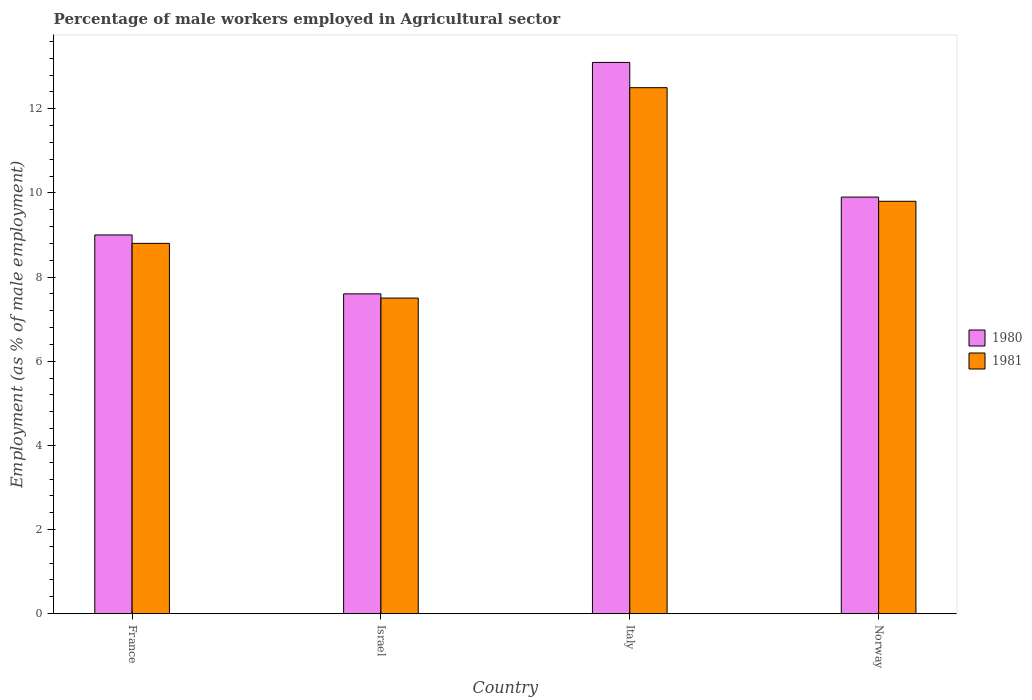Are the number of bars per tick equal to the number of legend labels?
Your response must be concise. Yes. What is the label of the 4th group of bars from the left?
Offer a terse response. Norway. In how many cases, is the number of bars for a given country not equal to the number of legend labels?
Offer a terse response. 0. Across all countries, what is the maximum percentage of male workers employed in Agricultural sector in 1981?
Keep it short and to the point. 12.5. Across all countries, what is the minimum percentage of male workers employed in Agricultural sector in 1980?
Your answer should be compact. 7.6. In which country was the percentage of male workers employed in Agricultural sector in 1981 minimum?
Your answer should be very brief. Israel. What is the total percentage of male workers employed in Agricultural sector in 1981 in the graph?
Keep it short and to the point. 38.6. What is the difference between the percentage of male workers employed in Agricultural sector in 1980 in Italy and that in Norway?
Your response must be concise. 3.2. What is the difference between the percentage of male workers employed in Agricultural sector in 1981 in France and the percentage of male workers employed in Agricultural sector in 1980 in Israel?
Your answer should be compact. 1.2. What is the average percentage of male workers employed in Agricultural sector in 1981 per country?
Offer a very short reply. 9.65. What is the difference between the percentage of male workers employed in Agricultural sector of/in 1981 and percentage of male workers employed in Agricultural sector of/in 1980 in Israel?
Provide a short and direct response. -0.1. In how many countries, is the percentage of male workers employed in Agricultural sector in 1980 greater than 6.4 %?
Keep it short and to the point. 4. What is the ratio of the percentage of male workers employed in Agricultural sector in 1981 in Italy to that in Norway?
Your answer should be compact. 1.28. Is the percentage of male workers employed in Agricultural sector in 1981 in Italy less than that in Norway?
Offer a very short reply. No. What is the difference between the highest and the second highest percentage of male workers employed in Agricultural sector in 1980?
Offer a terse response. -3.2. What is the difference between the highest and the lowest percentage of male workers employed in Agricultural sector in 1980?
Provide a succinct answer. 5.5. Is the sum of the percentage of male workers employed in Agricultural sector in 1980 in France and Italy greater than the maximum percentage of male workers employed in Agricultural sector in 1981 across all countries?
Give a very brief answer. Yes. How many bars are there?
Provide a short and direct response. 8. Does the graph contain any zero values?
Give a very brief answer. No. Does the graph contain grids?
Provide a succinct answer. No. How many legend labels are there?
Your response must be concise. 2. What is the title of the graph?
Offer a very short reply. Percentage of male workers employed in Agricultural sector. What is the label or title of the Y-axis?
Your answer should be very brief. Employment (as % of male employment). What is the Employment (as % of male employment) in 1980 in France?
Your answer should be compact. 9. What is the Employment (as % of male employment) of 1981 in France?
Make the answer very short. 8.8. What is the Employment (as % of male employment) in 1980 in Israel?
Provide a short and direct response. 7.6. What is the Employment (as % of male employment) in 1981 in Israel?
Offer a terse response. 7.5. What is the Employment (as % of male employment) in 1980 in Italy?
Make the answer very short. 13.1. What is the Employment (as % of male employment) in 1980 in Norway?
Provide a succinct answer. 9.9. What is the Employment (as % of male employment) of 1981 in Norway?
Make the answer very short. 9.8. Across all countries, what is the maximum Employment (as % of male employment) in 1980?
Keep it short and to the point. 13.1. Across all countries, what is the maximum Employment (as % of male employment) in 1981?
Provide a short and direct response. 12.5. Across all countries, what is the minimum Employment (as % of male employment) in 1980?
Keep it short and to the point. 7.6. What is the total Employment (as % of male employment) in 1980 in the graph?
Provide a short and direct response. 39.6. What is the total Employment (as % of male employment) in 1981 in the graph?
Keep it short and to the point. 38.6. What is the difference between the Employment (as % of male employment) in 1981 in France and that in Israel?
Your answer should be compact. 1.3. What is the difference between the Employment (as % of male employment) of 1980 in France and that in Italy?
Your answer should be very brief. -4.1. What is the difference between the Employment (as % of male employment) in 1981 in France and that in Italy?
Offer a terse response. -3.7. What is the difference between the Employment (as % of male employment) in 1980 in France and that in Norway?
Your response must be concise. -0.9. What is the difference between the Employment (as % of male employment) in 1980 in Israel and that in Italy?
Provide a short and direct response. -5.5. What is the difference between the Employment (as % of male employment) in 1980 in Israel and that in Norway?
Your response must be concise. -2.3. What is the difference between the Employment (as % of male employment) in 1981 in Israel and that in Norway?
Ensure brevity in your answer.  -2.3. What is the difference between the Employment (as % of male employment) of 1980 in Italy and that in Norway?
Provide a succinct answer. 3.2. What is the difference between the Employment (as % of male employment) in 1980 in France and the Employment (as % of male employment) in 1981 in Italy?
Give a very brief answer. -3.5. What is the difference between the Employment (as % of male employment) in 1980 in Israel and the Employment (as % of male employment) in 1981 in Italy?
Your response must be concise. -4.9. What is the difference between the Employment (as % of male employment) in 1980 in Israel and the Employment (as % of male employment) in 1981 in Norway?
Provide a short and direct response. -2.2. What is the average Employment (as % of male employment) in 1980 per country?
Your response must be concise. 9.9. What is the average Employment (as % of male employment) of 1981 per country?
Provide a short and direct response. 9.65. What is the difference between the Employment (as % of male employment) in 1980 and Employment (as % of male employment) in 1981 in Israel?
Ensure brevity in your answer.  0.1. What is the difference between the Employment (as % of male employment) in 1980 and Employment (as % of male employment) in 1981 in Italy?
Provide a short and direct response. 0.6. What is the ratio of the Employment (as % of male employment) of 1980 in France to that in Israel?
Your answer should be very brief. 1.18. What is the ratio of the Employment (as % of male employment) in 1981 in France to that in Israel?
Give a very brief answer. 1.17. What is the ratio of the Employment (as % of male employment) in 1980 in France to that in Italy?
Provide a short and direct response. 0.69. What is the ratio of the Employment (as % of male employment) in 1981 in France to that in Italy?
Offer a very short reply. 0.7. What is the ratio of the Employment (as % of male employment) of 1981 in France to that in Norway?
Provide a short and direct response. 0.9. What is the ratio of the Employment (as % of male employment) of 1980 in Israel to that in Italy?
Keep it short and to the point. 0.58. What is the ratio of the Employment (as % of male employment) of 1981 in Israel to that in Italy?
Offer a terse response. 0.6. What is the ratio of the Employment (as % of male employment) of 1980 in Israel to that in Norway?
Make the answer very short. 0.77. What is the ratio of the Employment (as % of male employment) of 1981 in Israel to that in Norway?
Make the answer very short. 0.77. What is the ratio of the Employment (as % of male employment) in 1980 in Italy to that in Norway?
Your response must be concise. 1.32. What is the ratio of the Employment (as % of male employment) in 1981 in Italy to that in Norway?
Ensure brevity in your answer.  1.28. What is the difference between the highest and the second highest Employment (as % of male employment) of 1981?
Your answer should be very brief. 2.7. 